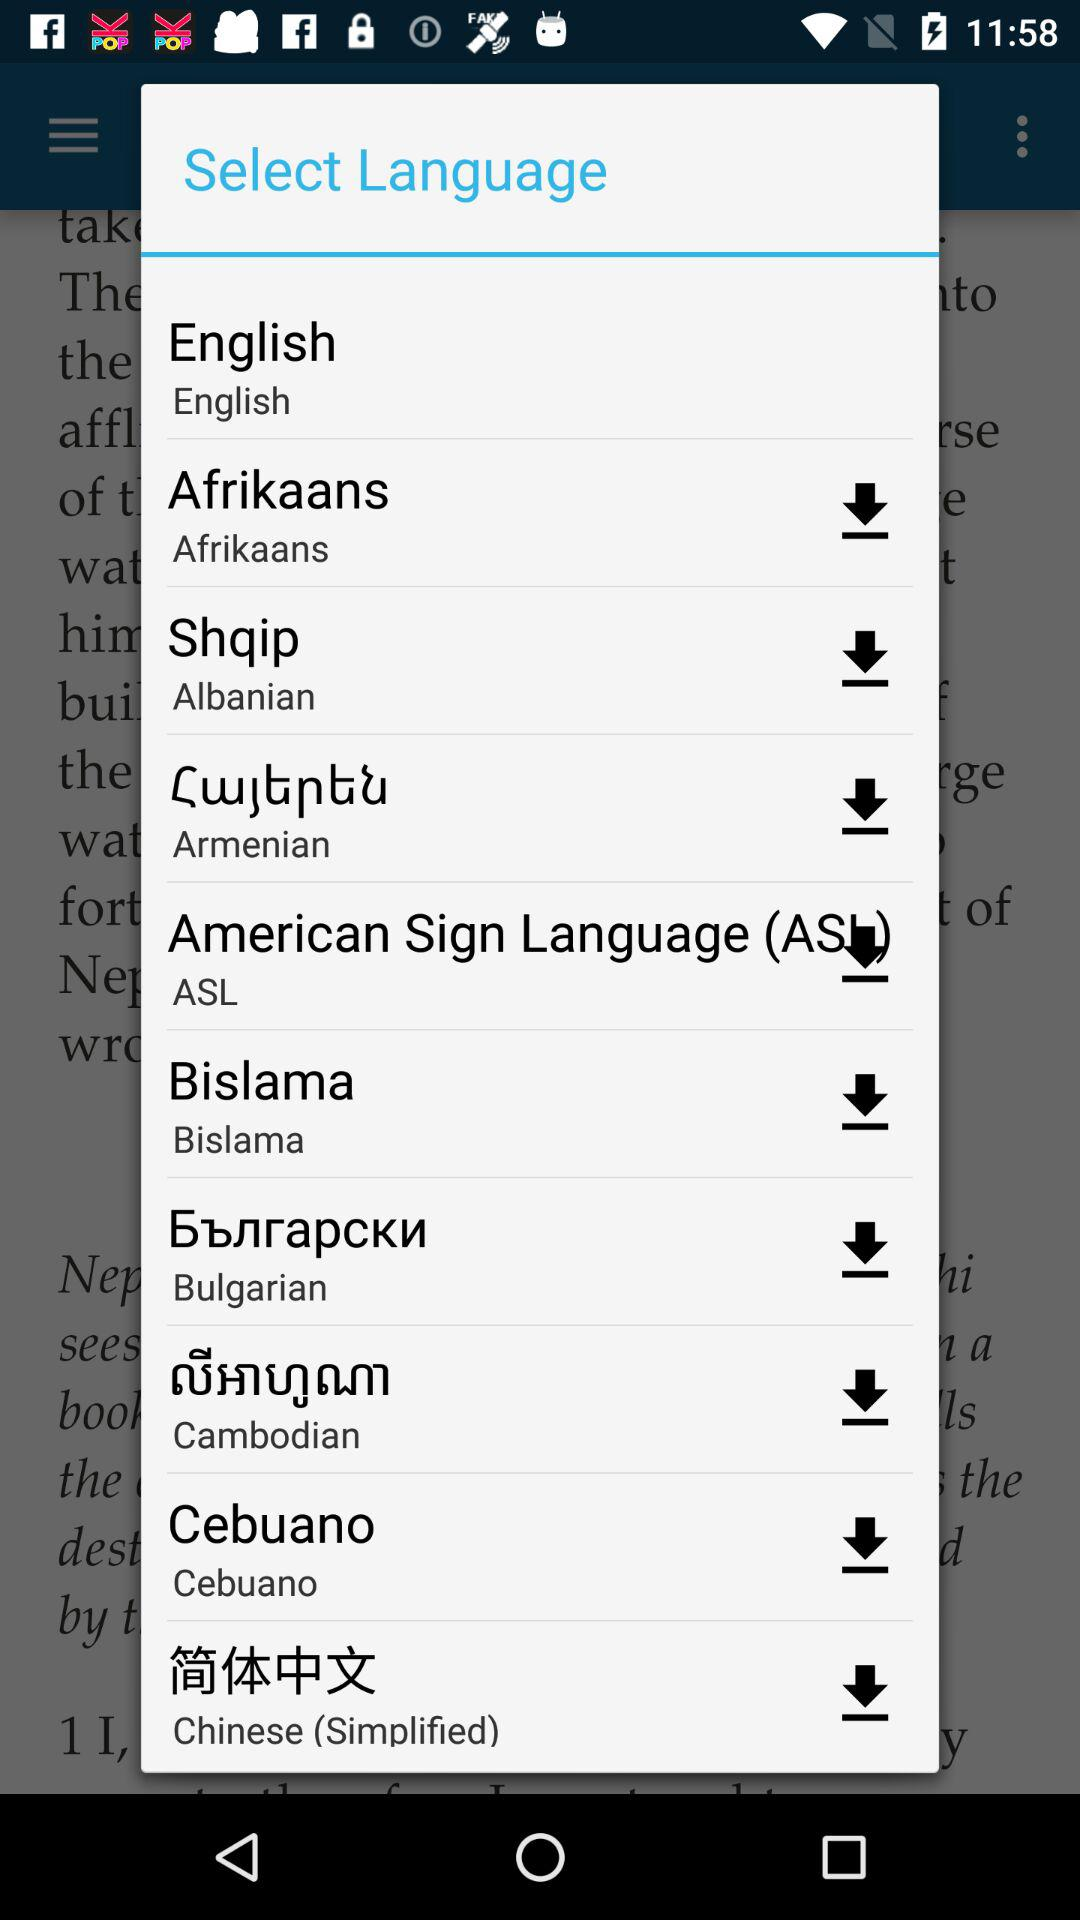What is the downloaded language? The downloaded language is English. 